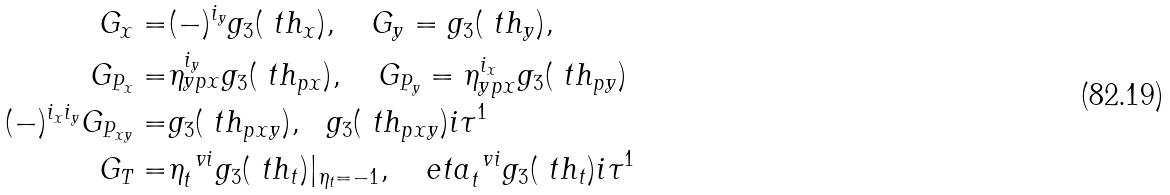Convert formula to latex. <formula><loc_0><loc_0><loc_500><loc_500>G _ { x } = & ( - ) ^ { i _ { y } } g _ { 3 } ( \ t h _ { x } ) , \quad G _ { y } = g _ { 3 } ( \ t h _ { y } ) , \\ G _ { P _ { x } } = & \eta _ { y p x } ^ { i _ { y } } g _ { 3 } ( \ t h _ { p x } ) , \quad G _ { P _ { y } } = \eta _ { y p x } ^ { i _ { x } } g _ { 3 } ( \ t h _ { p y } ) \\ ( - ) ^ { i _ { x } i _ { y } } G _ { P _ { x y } } = & g _ { 3 } ( \ t h _ { p x y } ) , \ \ g _ { 3 } ( \ t h _ { p x y } ) i \tau ^ { 1 } \\ G _ { T } = & \eta _ { t } ^ { \ v i } g _ { 3 } ( \ t h _ { t } ) | _ { \eta _ { t } = - 1 } , \ \ \ e t a _ { t } ^ { \ v i } g _ { 3 } ( \ t h _ { t } ) i \tau ^ { 1 }</formula> 